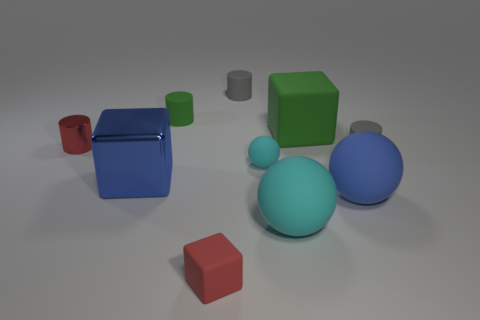Subtract all tiny spheres. How many spheres are left? 2 Subtract all blue spheres. How many spheres are left? 2 Subtract all red blocks. How many yellow balls are left? 0 Subtract all cylinders. How many objects are left? 6 Subtract 2 cubes. How many cubes are left? 1 Subtract all gray cubes. Subtract all green cylinders. How many cubes are left? 3 Subtract all cyan balls. Subtract all blue shiny blocks. How many objects are left? 7 Add 3 tiny green matte things. How many tiny green matte things are left? 4 Add 1 gray matte things. How many gray matte things exist? 3 Subtract 0 cyan cubes. How many objects are left? 10 